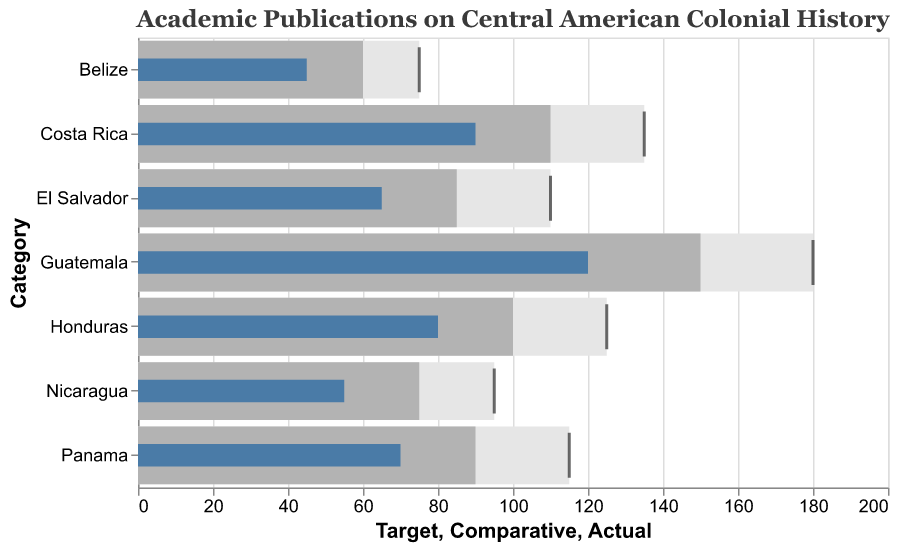What is the actual number of publications for Guatemala? The actual number of publications for Guatemala can be seen where the blue bar reaches on the x-axis.
Answer: 120 How many more publications does El Salvador need to meet its target? To find this, subtract El Salvador's actual number of publications from its target: 110 (target) - 65 (actual) = 45.
Answer: 45 Which sub-region has the highest number of actual publications? By comparing the lengths of the blue bars, Guatemala has the longest bar indicating the highest number of actual publications.
Answer: Guatemala Which sub-region is closest to meeting its comparative standard in terms of publications? To determine the closest match, find the smallest difference between the actual and comparative values across all sub-regions. Costa Rica has an actual of 90 and a comparative of 110, which is a difference of 20, the smallest among the sub-regions.
Answer: Costa Rica What is the average actual number of publications for Nicaragua and Panama combined? First, add the actual publications for Nicaragua and Panama: 55 (Nicaragua) + 70 (Panama) = 125. Then divide by 2 to find the average: 125 / 2 = 62.5.
Answer: 62.5 What is the total number of comparative publications for all the sub-regions? Add the comparative values for all sub-regions: 60 + 150 + 100 + 85 + 75 + 110 + 90 = 670.
Answer: 670 In which sub-region is the gap between actual publications and the target publications the largest? By computing the difference between the target and actual values, Guatemala shows the largest gap: 180 (target) - 120 (actual) = 60.
Answer: Guatemala Which sub-region has surpassed its comparative standard? A sub-region surpasses its comparative standard when its actual value is higher than its comparative value. No sub-region's actual publications surpass their comparative standards based on the chart.
Answer: None How many more publications does Belize need to reach the comparative standard? Subtract the actual number of publications in Belize from the comparative standard: 60 (comparative) - 45 (actual) = 15.
Answer: 15 